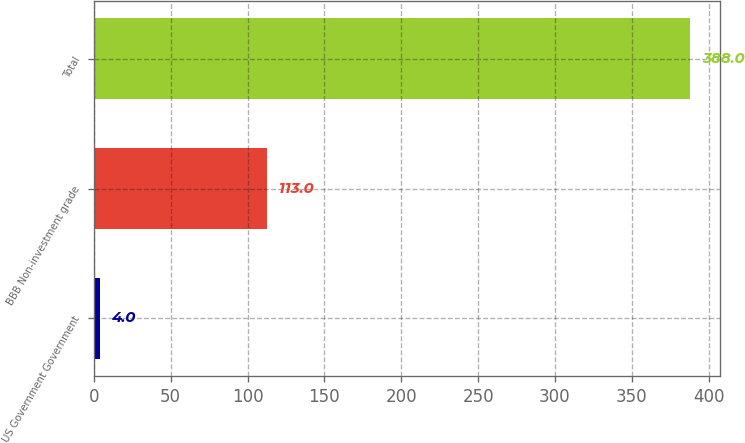Convert chart to OTSL. <chart><loc_0><loc_0><loc_500><loc_500><bar_chart><fcel>US Government Government<fcel>BBB Non-investment grade<fcel>Total<nl><fcel>4<fcel>113<fcel>388<nl></chart> 